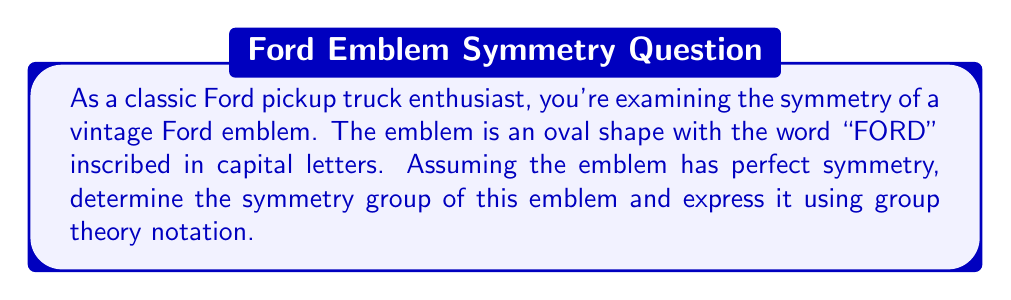Can you solve this math problem? To determine the symmetry group of the vintage Ford emblem, we need to consider all the symmetry operations that leave the emblem unchanged. Let's approach this step-by-step:

1. Rotational symmetry:
   The emblem has 2-fold rotational symmetry (180° rotation) around its center.

2. Reflection symmetry:
   - There is a horizontal line of reflection through the center of the oval.
   - There is a vertical line of reflection through the center of the oval.

3. Identity:
   The identity operation (doing nothing) is always a symmetry.

These symmetries form a group under composition. Let's define the elements:
- e: identity
- r: 180° rotation
- h: horizontal reflection
- v: vertical reflection

Now, let's construct the group table:

$$
\begin{array}{c|cccc}
   & e & r & h & v \\
\hline
e  & e & r & h & v \\
r  & r & e & v & h \\
h  & h & v & e & r \\
v  & v & h & r & e
\end{array}
$$

This group table is identical to the Klein four-group, also known as $V_4$ or $C_2 \times C_2$.

The group has the following properties:
1. It is abelian (commutative).
2. Every element is its own inverse.
3. It has order 4.

In terms of abstract algebra, this group is isomorphic to $\mathbb{Z}_2 \times \mathbb{Z}_2$, where $\mathbb{Z}_2$ is the cyclic group of order 2.
Answer: The symmetry group of the vintage Ford emblem is isomorphic to the Klein four-group, $V_4 \cong C_2 \times C_2 \cong \mathbb{Z}_2 \times \mathbb{Z}_2$. 